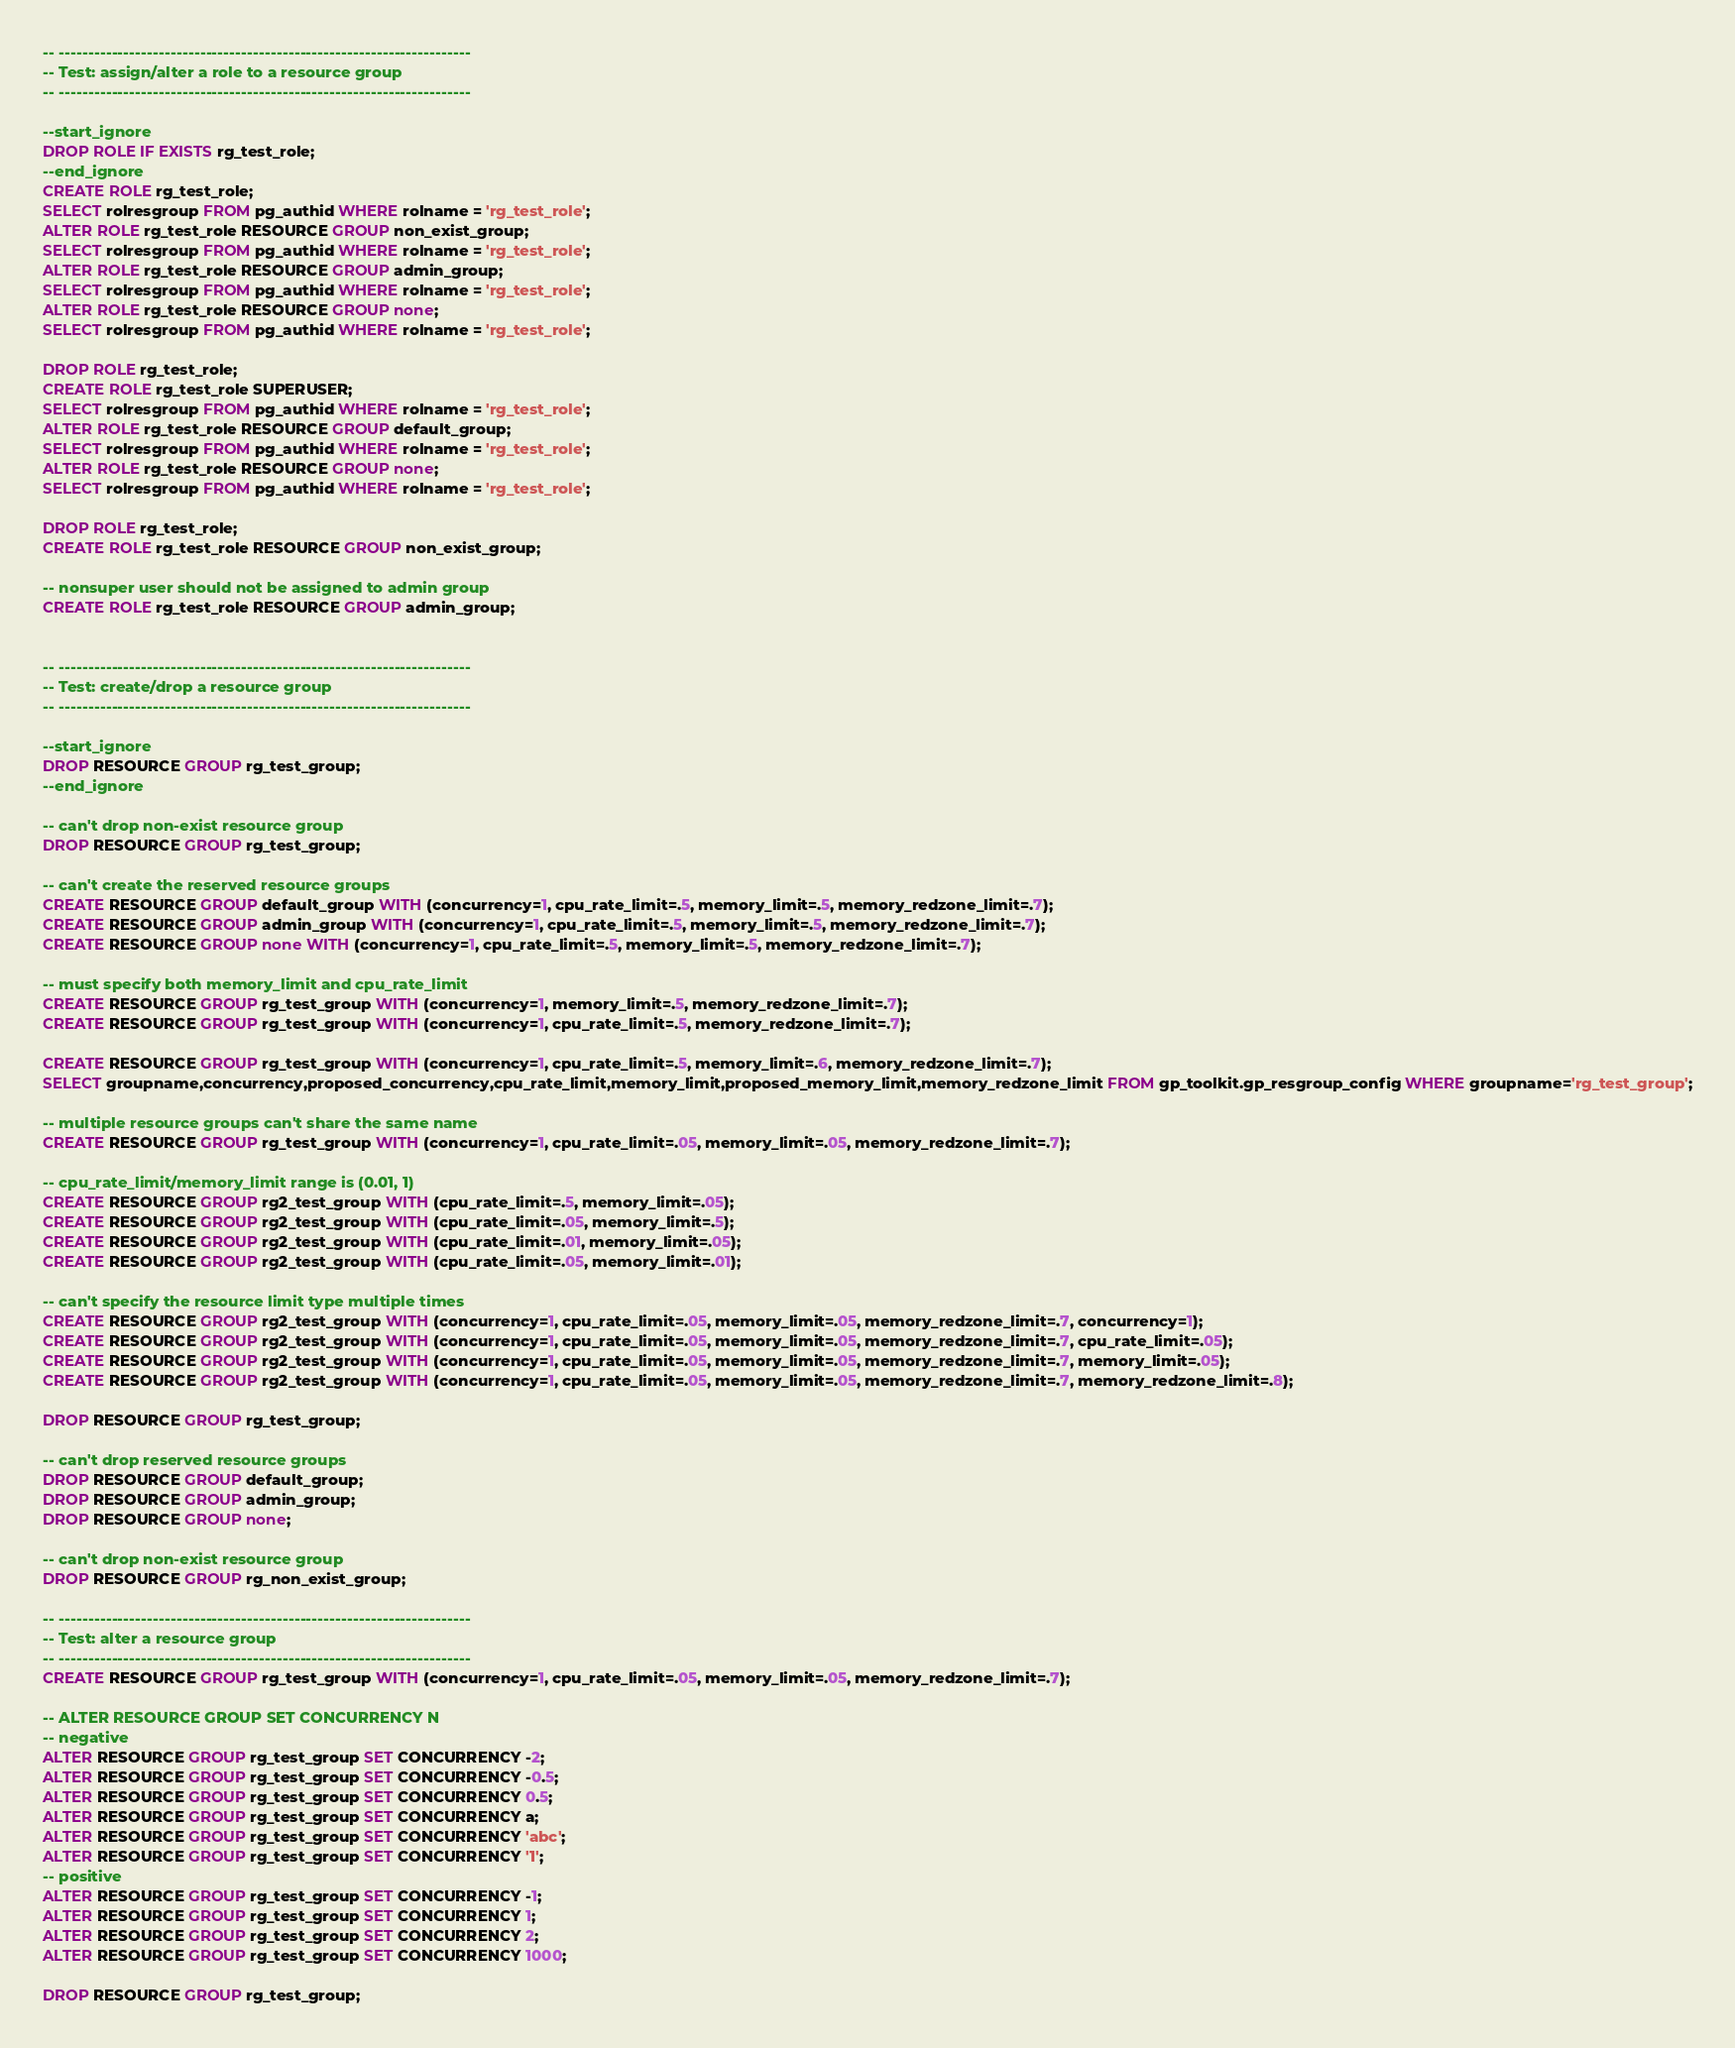Convert code to text. <code><loc_0><loc_0><loc_500><loc_500><_SQL_>-- ----------------------------------------------------------------------
-- Test: assign/alter a role to a resource group
-- ----------------------------------------------------------------------

--start_ignore
DROP ROLE IF EXISTS rg_test_role;
--end_ignore
CREATE ROLE rg_test_role;
SELECT rolresgroup FROM pg_authid WHERE rolname = 'rg_test_role';
ALTER ROLE rg_test_role RESOURCE GROUP non_exist_group;
SELECT rolresgroup FROM pg_authid WHERE rolname = 'rg_test_role';
ALTER ROLE rg_test_role RESOURCE GROUP admin_group;
SELECT rolresgroup FROM pg_authid WHERE rolname = 'rg_test_role';
ALTER ROLE rg_test_role RESOURCE GROUP none;
SELECT rolresgroup FROM pg_authid WHERE rolname = 'rg_test_role';

DROP ROLE rg_test_role;
CREATE ROLE rg_test_role SUPERUSER;
SELECT rolresgroup FROM pg_authid WHERE rolname = 'rg_test_role';
ALTER ROLE rg_test_role RESOURCE GROUP default_group;
SELECT rolresgroup FROM pg_authid WHERE rolname = 'rg_test_role';
ALTER ROLE rg_test_role RESOURCE GROUP none;
SELECT rolresgroup FROM pg_authid WHERE rolname = 'rg_test_role';

DROP ROLE rg_test_role;
CREATE ROLE rg_test_role RESOURCE GROUP non_exist_group;

-- nonsuper user should not be assigned to admin group
CREATE ROLE rg_test_role RESOURCE GROUP admin_group;


-- ----------------------------------------------------------------------
-- Test: create/drop a resource group
-- ----------------------------------------------------------------------

--start_ignore
DROP RESOURCE GROUP rg_test_group;
--end_ignore

-- can't drop non-exist resource group
DROP RESOURCE GROUP rg_test_group;

-- can't create the reserved resource groups
CREATE RESOURCE GROUP default_group WITH (concurrency=1, cpu_rate_limit=.5, memory_limit=.5, memory_redzone_limit=.7);
CREATE RESOURCE GROUP admin_group WITH (concurrency=1, cpu_rate_limit=.5, memory_limit=.5, memory_redzone_limit=.7);
CREATE RESOURCE GROUP none WITH (concurrency=1, cpu_rate_limit=.5, memory_limit=.5, memory_redzone_limit=.7);

-- must specify both memory_limit and cpu_rate_limit
CREATE RESOURCE GROUP rg_test_group WITH (concurrency=1, memory_limit=.5, memory_redzone_limit=.7);
CREATE RESOURCE GROUP rg_test_group WITH (concurrency=1, cpu_rate_limit=.5, memory_redzone_limit=.7);

CREATE RESOURCE GROUP rg_test_group WITH (concurrency=1, cpu_rate_limit=.5, memory_limit=.6, memory_redzone_limit=.7);
SELECT groupname,concurrency,proposed_concurrency,cpu_rate_limit,memory_limit,proposed_memory_limit,memory_redzone_limit FROM gp_toolkit.gp_resgroup_config WHERE groupname='rg_test_group';

-- multiple resource groups can't share the same name
CREATE RESOURCE GROUP rg_test_group WITH (concurrency=1, cpu_rate_limit=.05, memory_limit=.05, memory_redzone_limit=.7);

-- cpu_rate_limit/memory_limit range is (0.01, 1)
CREATE RESOURCE GROUP rg2_test_group WITH (cpu_rate_limit=.5, memory_limit=.05);
CREATE RESOURCE GROUP rg2_test_group WITH (cpu_rate_limit=.05, memory_limit=.5);
CREATE RESOURCE GROUP rg2_test_group WITH (cpu_rate_limit=.01, memory_limit=.05);
CREATE RESOURCE GROUP rg2_test_group WITH (cpu_rate_limit=.05, memory_limit=.01);

-- can't specify the resource limit type multiple times
CREATE RESOURCE GROUP rg2_test_group WITH (concurrency=1, cpu_rate_limit=.05, memory_limit=.05, memory_redzone_limit=.7, concurrency=1);
CREATE RESOURCE GROUP rg2_test_group WITH (concurrency=1, cpu_rate_limit=.05, memory_limit=.05, memory_redzone_limit=.7, cpu_rate_limit=.05);
CREATE RESOURCE GROUP rg2_test_group WITH (concurrency=1, cpu_rate_limit=.05, memory_limit=.05, memory_redzone_limit=.7, memory_limit=.05);
CREATE RESOURCE GROUP rg2_test_group WITH (concurrency=1, cpu_rate_limit=.05, memory_limit=.05, memory_redzone_limit=.7, memory_redzone_limit=.8);

DROP RESOURCE GROUP rg_test_group;

-- can't drop reserved resource groups
DROP RESOURCE GROUP default_group;
DROP RESOURCE GROUP admin_group;
DROP RESOURCE GROUP none;

-- can't drop non-exist resource group
DROP RESOURCE GROUP rg_non_exist_group;

-- ----------------------------------------------------------------------
-- Test: alter a resource group
-- ----------------------------------------------------------------------
CREATE RESOURCE GROUP rg_test_group WITH (concurrency=1, cpu_rate_limit=.05, memory_limit=.05, memory_redzone_limit=.7);

-- ALTER RESOURCE GROUP SET CONCURRENCY N
-- negative
ALTER RESOURCE GROUP rg_test_group SET CONCURRENCY -2;
ALTER RESOURCE GROUP rg_test_group SET CONCURRENCY -0.5;
ALTER RESOURCE GROUP rg_test_group SET CONCURRENCY 0.5;
ALTER RESOURCE GROUP rg_test_group SET CONCURRENCY a;
ALTER RESOURCE GROUP rg_test_group SET CONCURRENCY 'abc';
ALTER RESOURCE GROUP rg_test_group SET CONCURRENCY '1';
-- positive 
ALTER RESOURCE GROUP rg_test_group SET CONCURRENCY -1;
ALTER RESOURCE GROUP rg_test_group SET CONCURRENCY 1;
ALTER RESOURCE GROUP rg_test_group SET CONCURRENCY 2;
ALTER RESOURCE GROUP rg_test_group SET CONCURRENCY 1000;

DROP RESOURCE GROUP rg_test_group;
</code> 